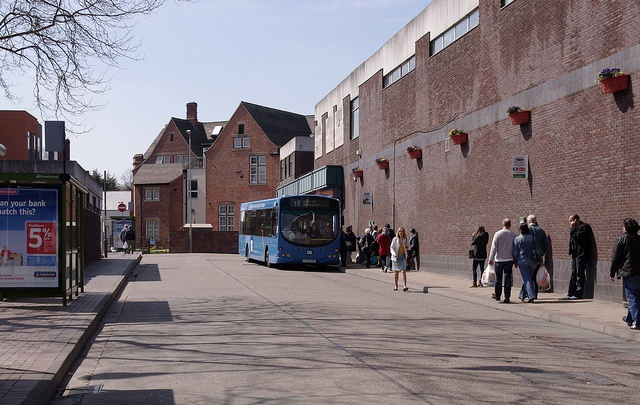Describe the objects in this image and their specific colors. I can see bus in gray, black, and navy tones, people in gray, black, navy, and darkblue tones, people in gray, black, lightgray, and darkgray tones, people in gray, black, darkgray, and maroon tones, and people in gray, black, and navy tones in this image. 